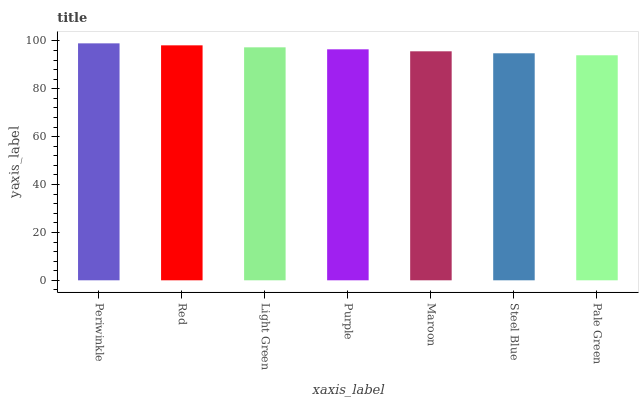Is Red the minimum?
Answer yes or no. No. Is Red the maximum?
Answer yes or no. No. Is Periwinkle greater than Red?
Answer yes or no. Yes. Is Red less than Periwinkle?
Answer yes or no. Yes. Is Red greater than Periwinkle?
Answer yes or no. No. Is Periwinkle less than Red?
Answer yes or no. No. Is Purple the high median?
Answer yes or no. Yes. Is Purple the low median?
Answer yes or no. Yes. Is Pale Green the high median?
Answer yes or no. No. Is Pale Green the low median?
Answer yes or no. No. 